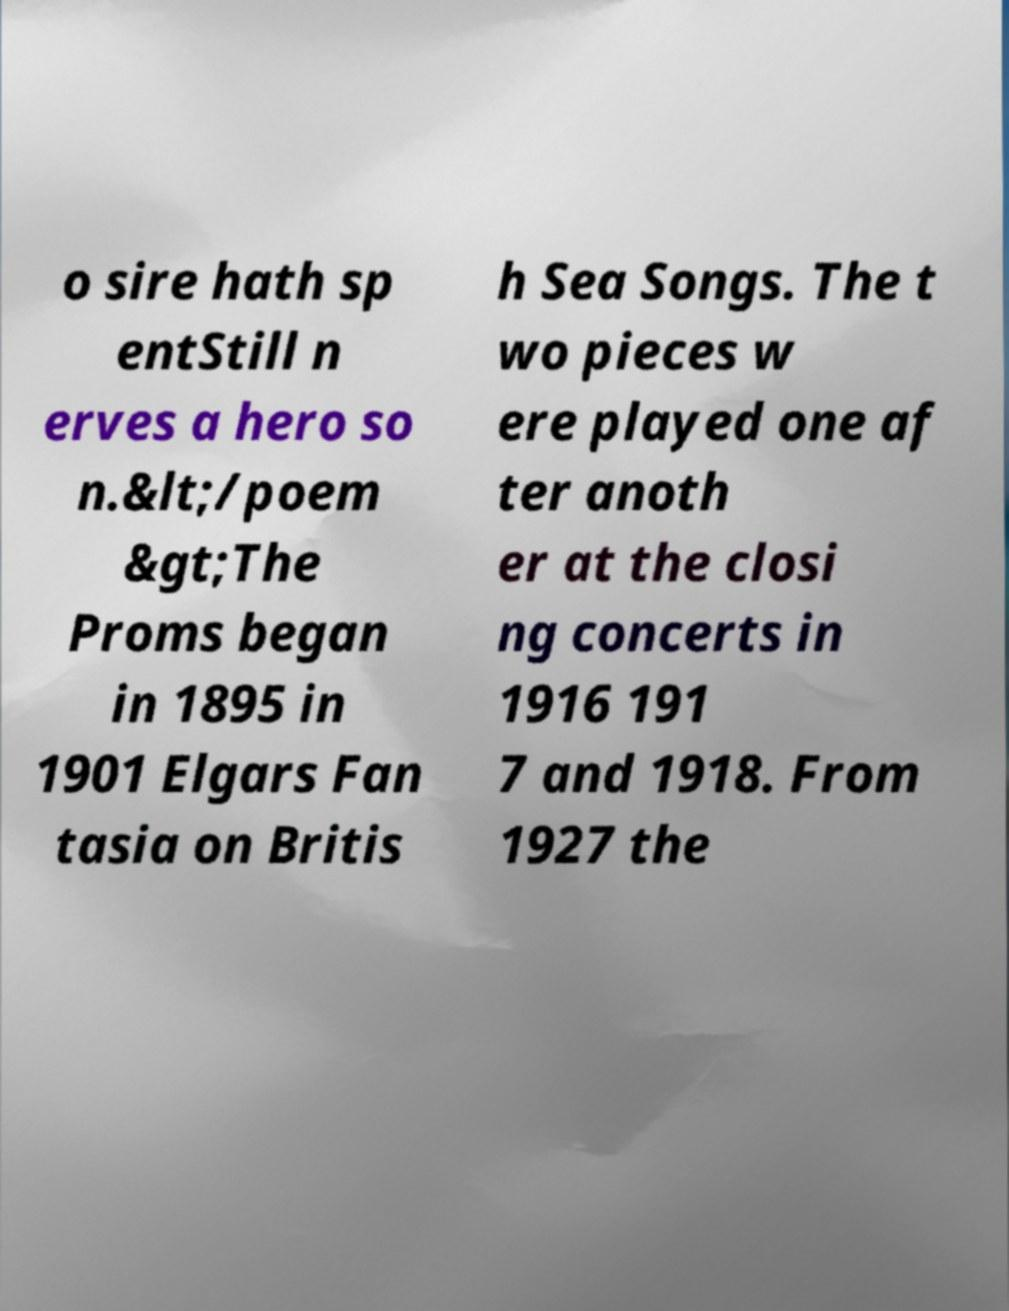What messages or text are displayed in this image? I need them in a readable, typed format. o sire hath sp entStill n erves a hero so n.&lt;/poem &gt;The Proms began in 1895 in 1901 Elgars Fan tasia on Britis h Sea Songs. The t wo pieces w ere played one af ter anoth er at the closi ng concerts in 1916 191 7 and 1918. From 1927 the 